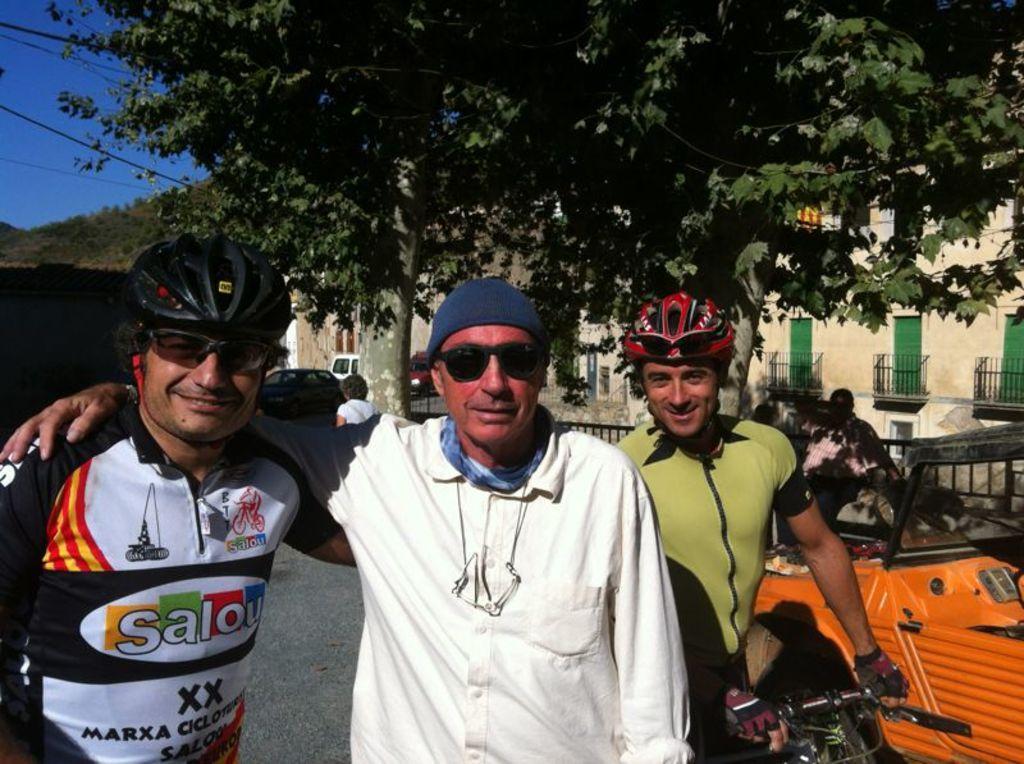Describe this image in one or two sentences. In this picture this 3 persons are highlighted. This 2 persons wore a helmet. This person is sitting on a bicycle. Beside this person there is a vehicle in orange color. Far there are trees and buildings. 